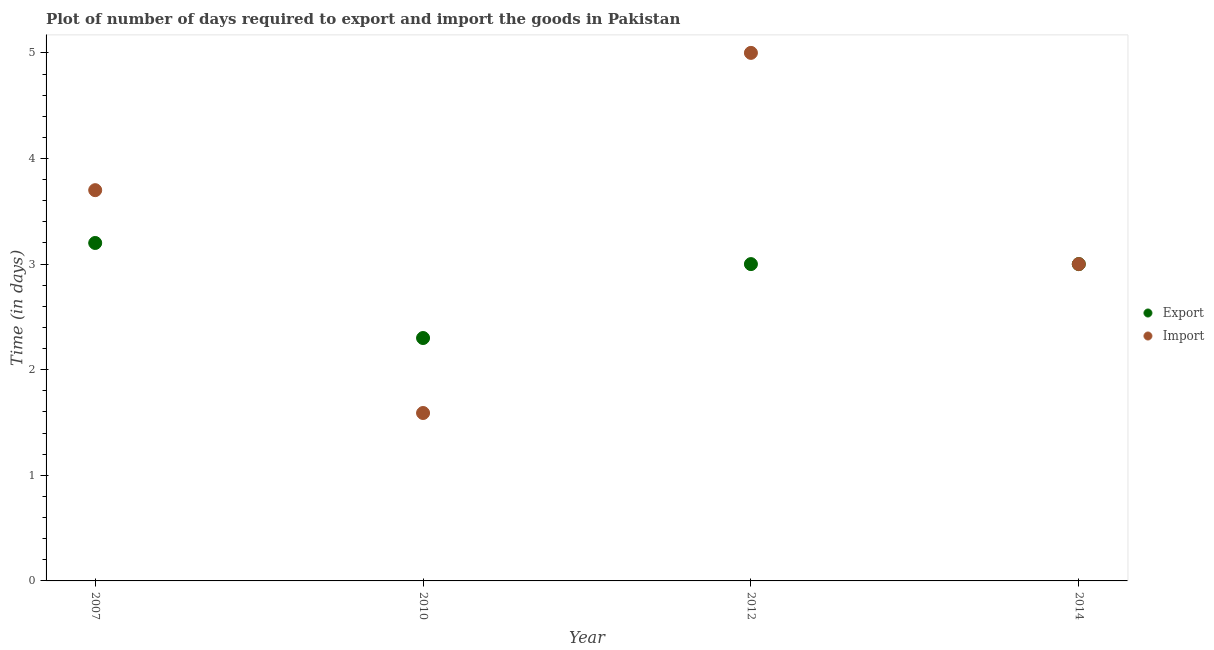How many different coloured dotlines are there?
Make the answer very short. 2. Is the number of dotlines equal to the number of legend labels?
Make the answer very short. Yes. Across all years, what is the maximum time required to export?
Provide a succinct answer. 3.2. Across all years, what is the minimum time required to import?
Keep it short and to the point. 1.59. What is the total time required to import in the graph?
Your answer should be compact. 13.29. What is the difference between the time required to import in 2010 and that in 2012?
Offer a terse response. -3.41. What is the difference between the time required to import in 2014 and the time required to export in 2012?
Keep it short and to the point. 0. What is the average time required to export per year?
Provide a succinct answer. 2.88. In the year 2014, what is the difference between the time required to import and time required to export?
Provide a short and direct response. 0. What is the ratio of the time required to import in 2010 to that in 2014?
Offer a very short reply. 0.53. Is the difference between the time required to import in 2010 and 2014 greater than the difference between the time required to export in 2010 and 2014?
Provide a short and direct response. No. What is the difference between the highest and the second highest time required to import?
Give a very brief answer. 1.3. What is the difference between the highest and the lowest time required to import?
Give a very brief answer. 3.41. In how many years, is the time required to export greater than the average time required to export taken over all years?
Offer a very short reply. 3. Does the time required to import monotonically increase over the years?
Offer a very short reply. No. Is the time required to import strictly greater than the time required to export over the years?
Give a very brief answer. No. How many dotlines are there?
Your answer should be compact. 2. How many years are there in the graph?
Keep it short and to the point. 4. Are the values on the major ticks of Y-axis written in scientific E-notation?
Your answer should be compact. No. Does the graph contain any zero values?
Give a very brief answer. No. What is the title of the graph?
Offer a terse response. Plot of number of days required to export and import the goods in Pakistan. Does "Subsidies" appear as one of the legend labels in the graph?
Ensure brevity in your answer.  No. What is the label or title of the Y-axis?
Give a very brief answer. Time (in days). What is the Time (in days) of Import in 2010?
Keep it short and to the point. 1.59. What is the Time (in days) of Export in 2012?
Your answer should be very brief. 3. What is the Time (in days) in Import in 2012?
Ensure brevity in your answer.  5. What is the Time (in days) of Export in 2014?
Ensure brevity in your answer.  3. What is the Time (in days) of Import in 2014?
Keep it short and to the point. 3. Across all years, what is the maximum Time (in days) of Import?
Make the answer very short. 5. Across all years, what is the minimum Time (in days) of Export?
Make the answer very short. 2.3. Across all years, what is the minimum Time (in days) of Import?
Offer a very short reply. 1.59. What is the total Time (in days) in Import in the graph?
Ensure brevity in your answer.  13.29. What is the difference between the Time (in days) in Export in 2007 and that in 2010?
Ensure brevity in your answer.  0.9. What is the difference between the Time (in days) in Import in 2007 and that in 2010?
Give a very brief answer. 2.11. What is the difference between the Time (in days) in Export in 2007 and that in 2014?
Ensure brevity in your answer.  0.2. What is the difference between the Time (in days) of Import in 2007 and that in 2014?
Keep it short and to the point. 0.7. What is the difference between the Time (in days) in Export in 2010 and that in 2012?
Ensure brevity in your answer.  -0.7. What is the difference between the Time (in days) of Import in 2010 and that in 2012?
Your response must be concise. -3.41. What is the difference between the Time (in days) in Export in 2010 and that in 2014?
Your answer should be very brief. -0.7. What is the difference between the Time (in days) in Import in 2010 and that in 2014?
Make the answer very short. -1.41. What is the difference between the Time (in days) in Import in 2012 and that in 2014?
Your response must be concise. 2. What is the difference between the Time (in days) in Export in 2007 and the Time (in days) in Import in 2010?
Your answer should be compact. 1.61. What is the difference between the Time (in days) in Export in 2010 and the Time (in days) in Import in 2012?
Provide a short and direct response. -2.7. What is the difference between the Time (in days) of Export in 2012 and the Time (in days) of Import in 2014?
Ensure brevity in your answer.  0. What is the average Time (in days) of Export per year?
Keep it short and to the point. 2.88. What is the average Time (in days) in Import per year?
Ensure brevity in your answer.  3.32. In the year 2010, what is the difference between the Time (in days) in Export and Time (in days) in Import?
Keep it short and to the point. 0.71. What is the ratio of the Time (in days) of Export in 2007 to that in 2010?
Your response must be concise. 1.39. What is the ratio of the Time (in days) of Import in 2007 to that in 2010?
Your response must be concise. 2.33. What is the ratio of the Time (in days) of Export in 2007 to that in 2012?
Your response must be concise. 1.07. What is the ratio of the Time (in days) of Import in 2007 to that in 2012?
Offer a very short reply. 0.74. What is the ratio of the Time (in days) in Export in 2007 to that in 2014?
Offer a terse response. 1.07. What is the ratio of the Time (in days) in Import in 2007 to that in 2014?
Make the answer very short. 1.23. What is the ratio of the Time (in days) in Export in 2010 to that in 2012?
Provide a short and direct response. 0.77. What is the ratio of the Time (in days) in Import in 2010 to that in 2012?
Make the answer very short. 0.32. What is the ratio of the Time (in days) in Export in 2010 to that in 2014?
Provide a short and direct response. 0.77. What is the ratio of the Time (in days) in Import in 2010 to that in 2014?
Your answer should be compact. 0.53. What is the difference between the highest and the second highest Time (in days) of Import?
Keep it short and to the point. 1.3. What is the difference between the highest and the lowest Time (in days) of Export?
Ensure brevity in your answer.  0.9. What is the difference between the highest and the lowest Time (in days) in Import?
Provide a short and direct response. 3.41. 